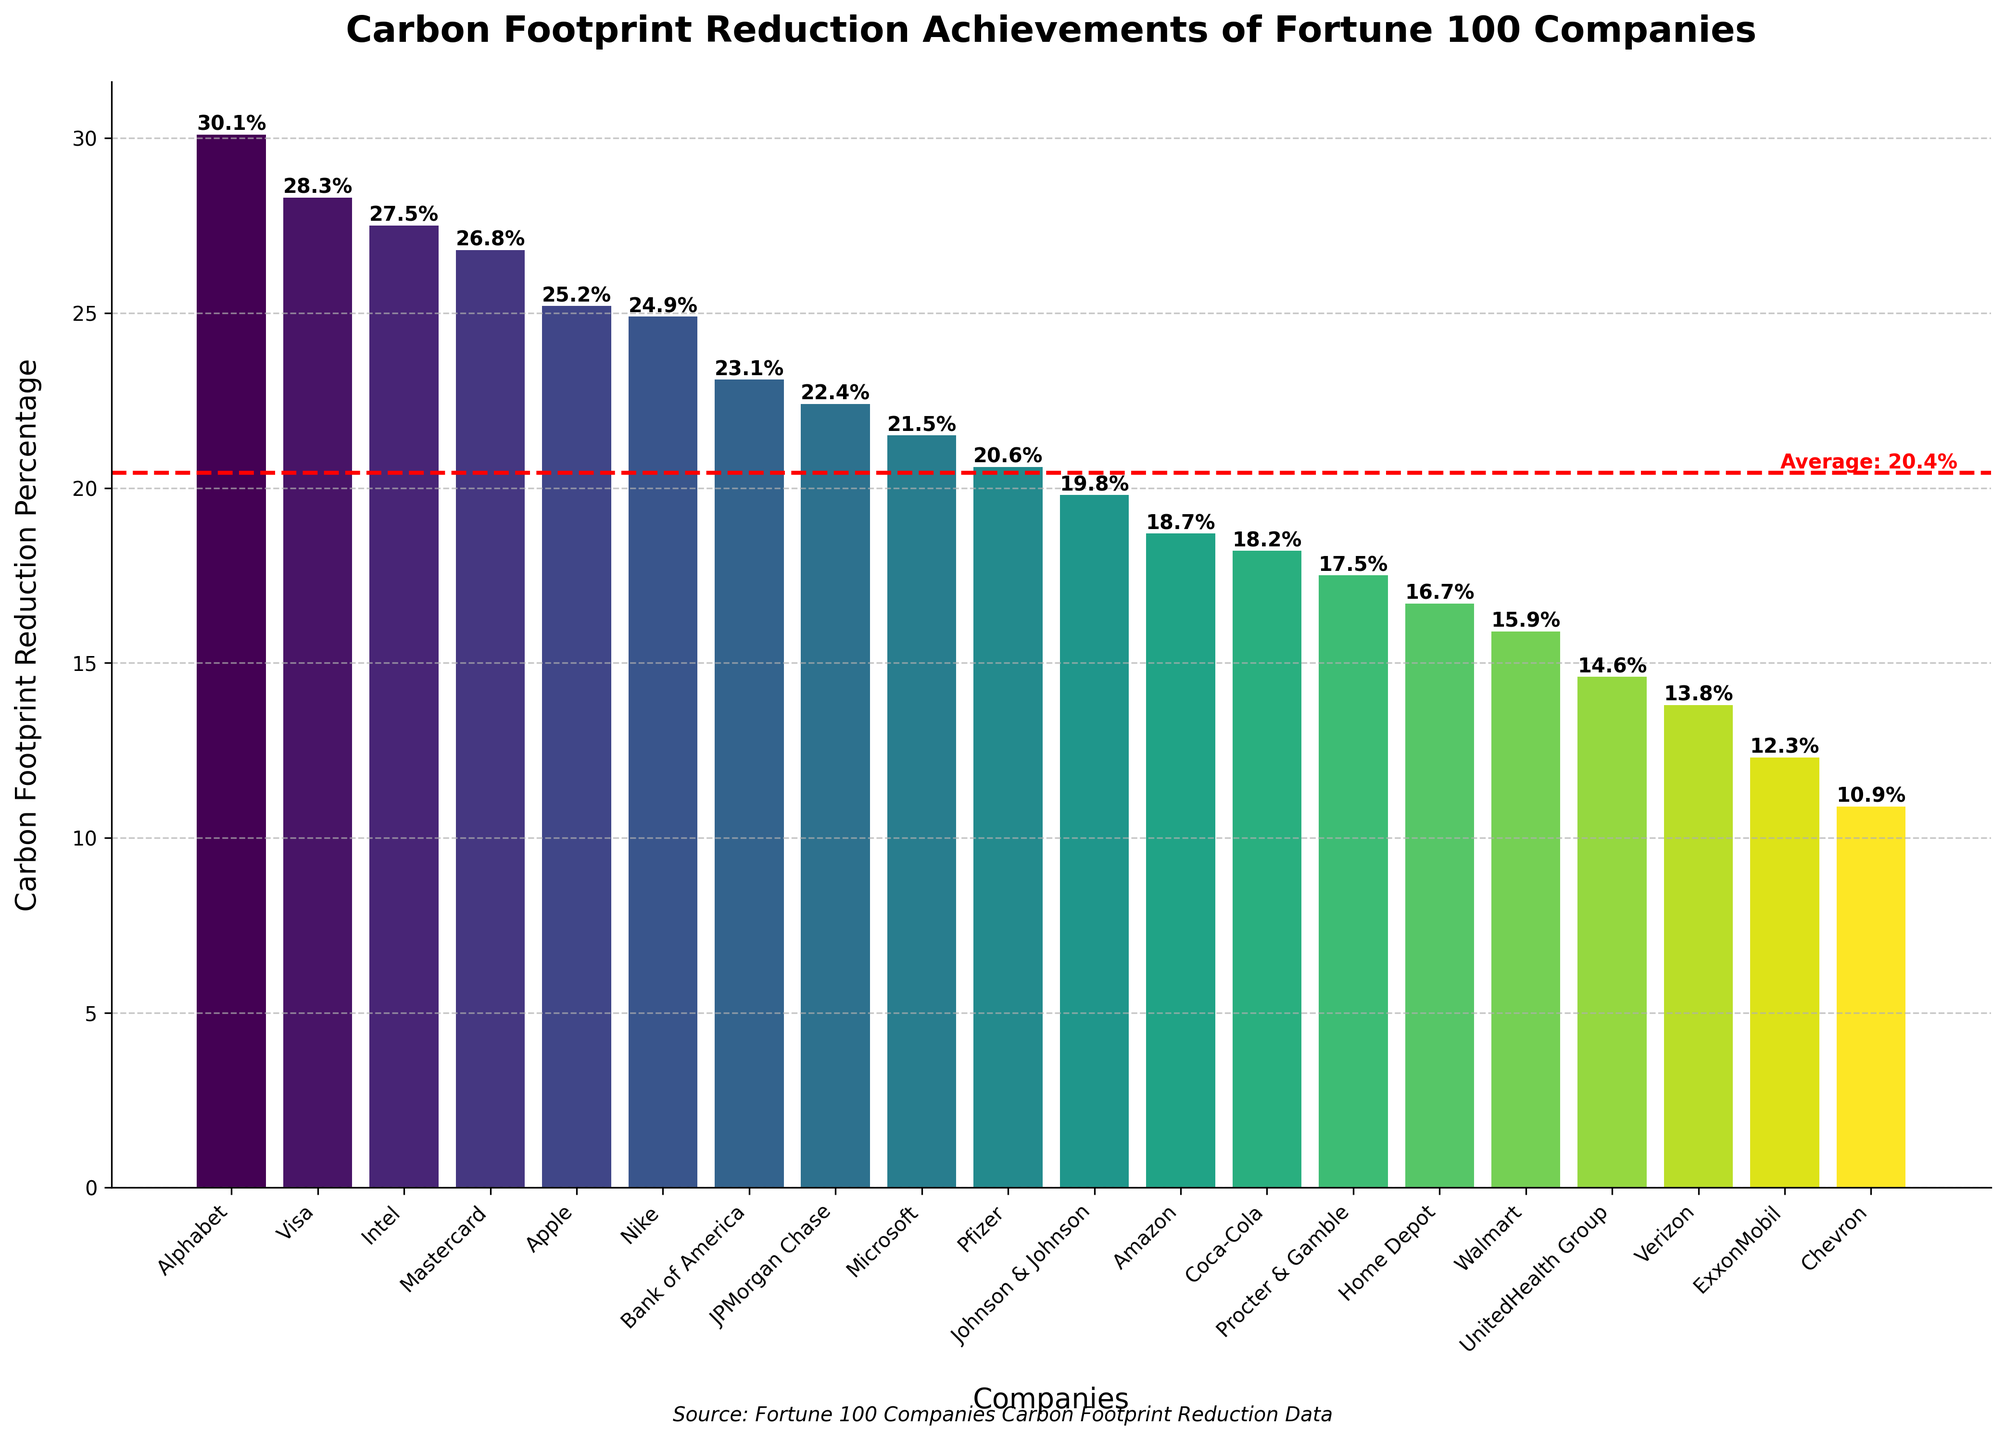What's the average carbon footprint reduction percentage achieved by these companies? To find the average reduction percentage, sum all the reduction percentages and divide by the number of companies. The total reduction percentage is 384.2. There are 20 companies, so the average reduction percentage is 384.2 / 20
Answer: 19.2% Which company has achieved the highest carbon footprint reduction? Look at the heights of the bars and identify the tallest one, which represents Alphabet at approximately 30.1%.
Answer: Alphabet How does Visa's carbon footprint reduction compare to Apple's? Compare the height of Visa’s bar to Apple’s bar. Visa achieved 28.3%, which is slightly higher than Apple's 25.2%.
Answer: Visa's reduction is higher What is the reduction percentage difference between ExxonMobil and Chevron? Find the heights of the bars representing ExxonMobil and Chevron. ExxonMobil's reduction is 12.3%, and Chevron's reduction is 10.9%. The difference is 12.3% - 10.9%.
Answer: 1.4% Is the carbon footprint reduction of Walmart below or above the average? Identify Walmart's bar and compare its value (15.9%) to the average reduction percentage (19.2%). Walmart's reduction is below the average.
Answer: Below How many companies have a reduction percentage above 25%? Count the bars with heights above 25%. These companies are Apple, Alphabet, Visa, Mastercard, and Intel. There are 5 such companies.
Answer: 5 Which companies achieve a reduction percentage between 20% and 25%? Identify bars within the range of 20% to 25%. These companies are Microsoft, JPMorgan Chase, Bank of America, Nike, and Apple.
Answer: Microsoft, JPMorgan Chase, Bank of America, Nike, Apple What is the combined carbon footprint reduction percentage of the top three companies? Look at the top three highest bars representing Alphabet (30.1%), Intel (27.5%), and Mastercard (26.8%) and add their reduction percentages together: 30.1% + 27.5% + 26.8%.
Answer: 84.4% Which company has the lowest carbon footprint reduction, and what is its value? Identify the shortest bar which represents Chevron, with a reduction percentage of 10.9%.
Answer: Chevron, 10.9% What visual cues indicate the average carbon footprint reduction percentage on the chart? The average reduction percentage is represented by a red dashed horizontal line across the chart, with a label indicating the average value (19.2%).
Answer: Red dashed line and label How does ExxonMobil's carbon footprint reduction achievement compare to the average reduction? Compare the height of ExxonMobil’s bar (12.3%) to the horizontal red dashed line representing the average (19.2%). ExxonMobil’s reduction is below average.
Answer: Below average 